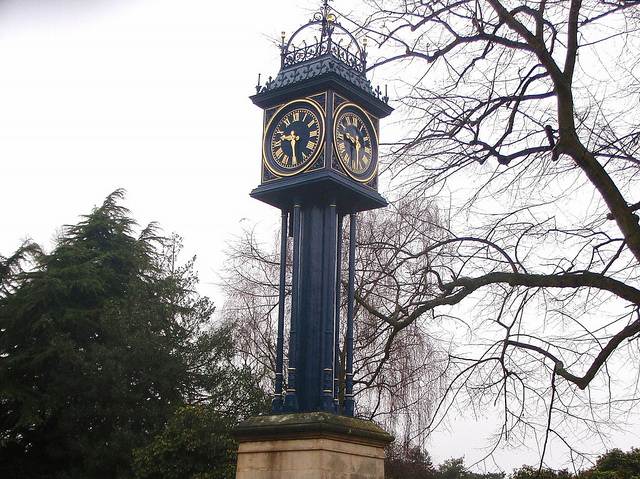The number on this clock face are known as what type of numerals? The numbers on the clock face are known as Roman numerals, which are a numeral system originating in ancient Rome. They use combinations of letters from the Latin alphabet (I, V, X, L, C, D, and M) to represent numbers. Roman numerals are often used on clock faces to provide a classic and traditional appearance. 